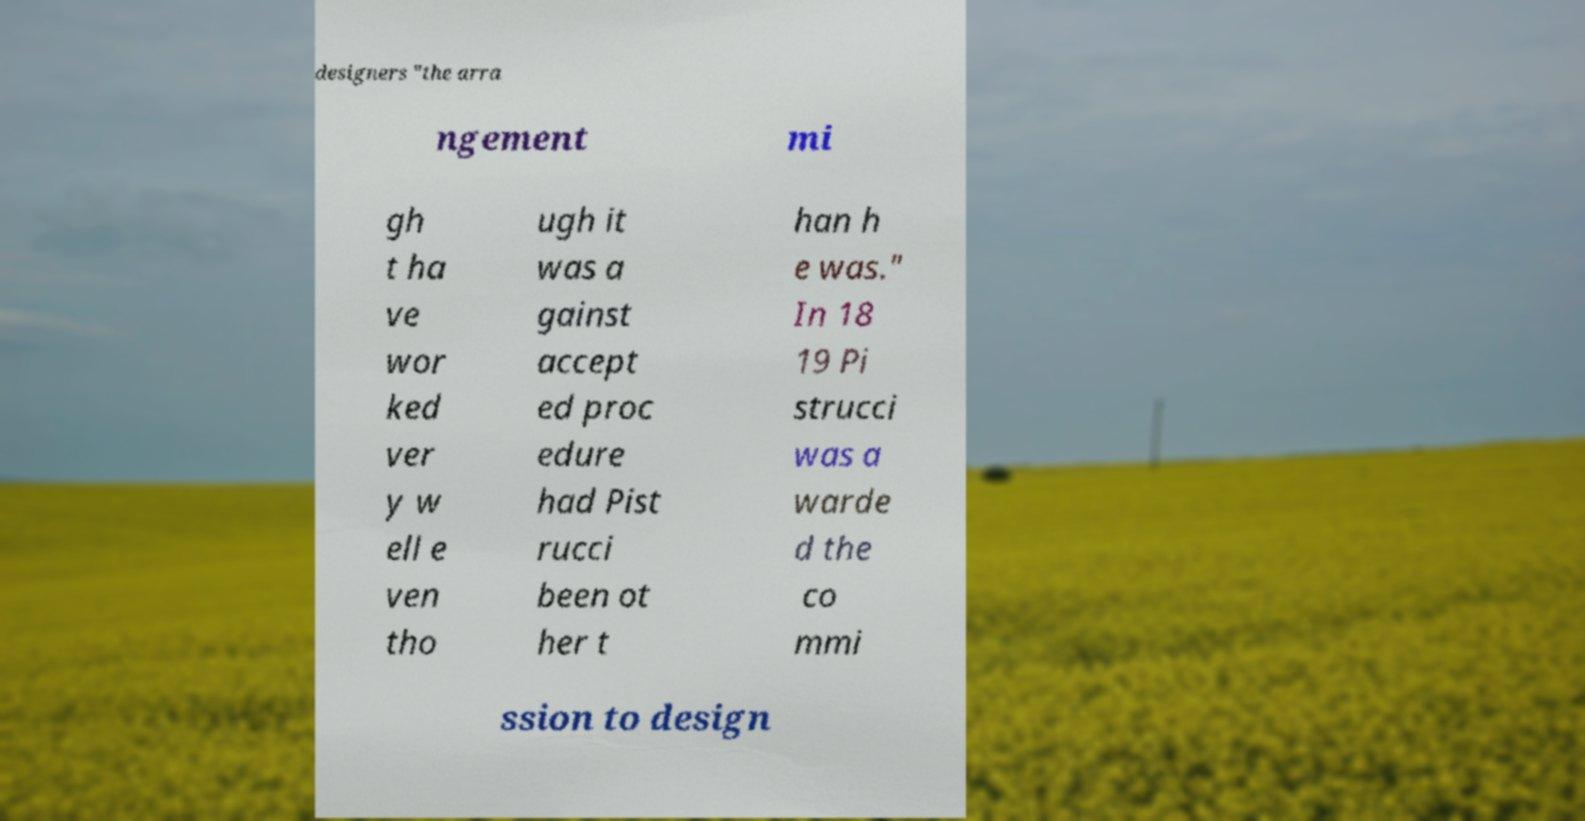Could you assist in decoding the text presented in this image and type it out clearly? designers "the arra ngement mi gh t ha ve wor ked ver y w ell e ven tho ugh it was a gainst accept ed proc edure had Pist rucci been ot her t han h e was." In 18 19 Pi strucci was a warde d the co mmi ssion to design 